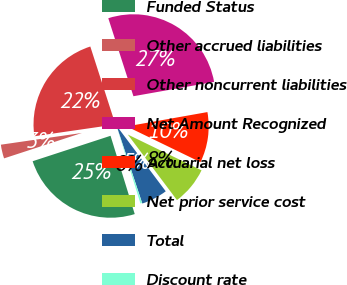Convert chart. <chart><loc_0><loc_0><loc_500><loc_500><pie_chart><fcel>Funded Status<fcel>Other accrued liabilities<fcel>Other noncurrent liabilities<fcel>Net Amount Recognized<fcel>Actuarial net loss<fcel>Net prior service cost<fcel>Total<fcel>Discount rate<nl><fcel>24.75%<fcel>2.73%<fcel>22.33%<fcel>27.17%<fcel>9.99%<fcel>7.57%<fcel>5.15%<fcel>0.32%<nl></chart> 